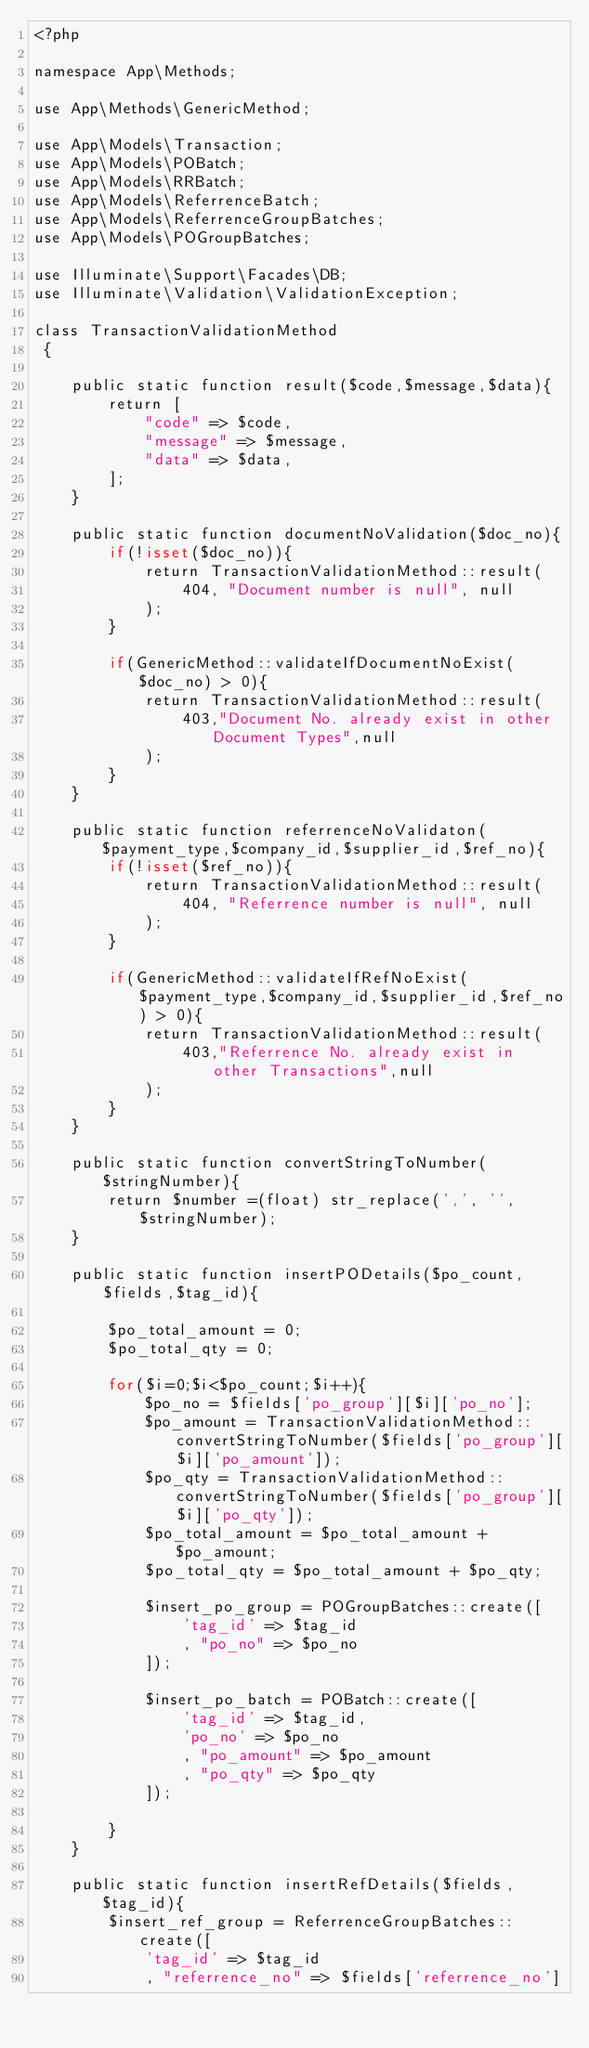<code> <loc_0><loc_0><loc_500><loc_500><_PHP_><?php

namespace App\Methods;

use App\Methods\GenericMethod;

use App\Models\Transaction;
use App\Models\POBatch;
use App\Models\RRBatch;
use App\Models\ReferrenceBatch;
use App\Models\ReferrenceGroupBatches;
use App\Models\POGroupBatches;

use Illuminate\Support\Facades\DB;
use Illuminate\Validation\ValidationException;

class TransactionValidationMethod
 {

    public static function result($code,$message,$data){
        return [
            "code" => $code,
            "message" => $message,
            "data" => $data,
        ];
    }

    public static function documentNoValidation($doc_no){
        if(!isset($doc_no)){
            return TransactionValidationMethod::result(
                404, "Document number is null", null
            );
        }

        if(GenericMethod::validateIfDocumentNoExist($doc_no) > 0){
            return TransactionValidationMethod::result(
                403,"Document No. already exist in other Document Types",null
            );
        }
    }

    public static function referrenceNoValidaton($payment_type,$company_id,$supplier_id,$ref_no){
        if(!isset($ref_no)){
            return TransactionValidationMethod::result(
                404, "Referrence number is null", null
            );
        }

        if(GenericMethod::validateIfRefNoExist($payment_type,$company_id,$supplier_id,$ref_no) > 0){
            return TransactionValidationMethod::result(
                403,"Referrence No. already exist in other Transactions",null
            );
        }
    }

    public static function convertStringToNumber($stringNumber){
        return $number =(float) str_replace(',', '', $stringNumber);
    }

    public static function insertPODetails($po_count,$fields,$tag_id){

        $po_total_amount = 0;
        $po_total_qty = 0;

        for($i=0;$i<$po_count;$i++){
            $po_no = $fields['po_group'][$i]['po_no'];
            $po_amount = TransactionValidationMethod::convertStringToNumber($fields['po_group'][$i]['po_amount']);
            $po_qty = TransactionValidationMethod::convertStringToNumber($fields['po_group'][$i]['po_qty']);
            $po_total_amount = $po_total_amount + $po_amount;
            $po_total_qty = $po_total_amount + $po_qty;

            $insert_po_group = POGroupBatches::create([
                'tag_id' => $tag_id
                , "po_no" => $po_no
            ]);

            $insert_po_batch = POBatch::create([
                'tag_id' => $tag_id,
                'po_no' => $po_no
                , "po_amount" => $po_amount
                , "po_qty" => $po_qty
            ]);

        }
    }

    public static function insertRefDetails($fields,$tag_id){
        $insert_ref_group = ReferrenceGroupBatches::create([
            'tag_id' => $tag_id
            , "referrence_no" => $fields['referrence_no']</code> 